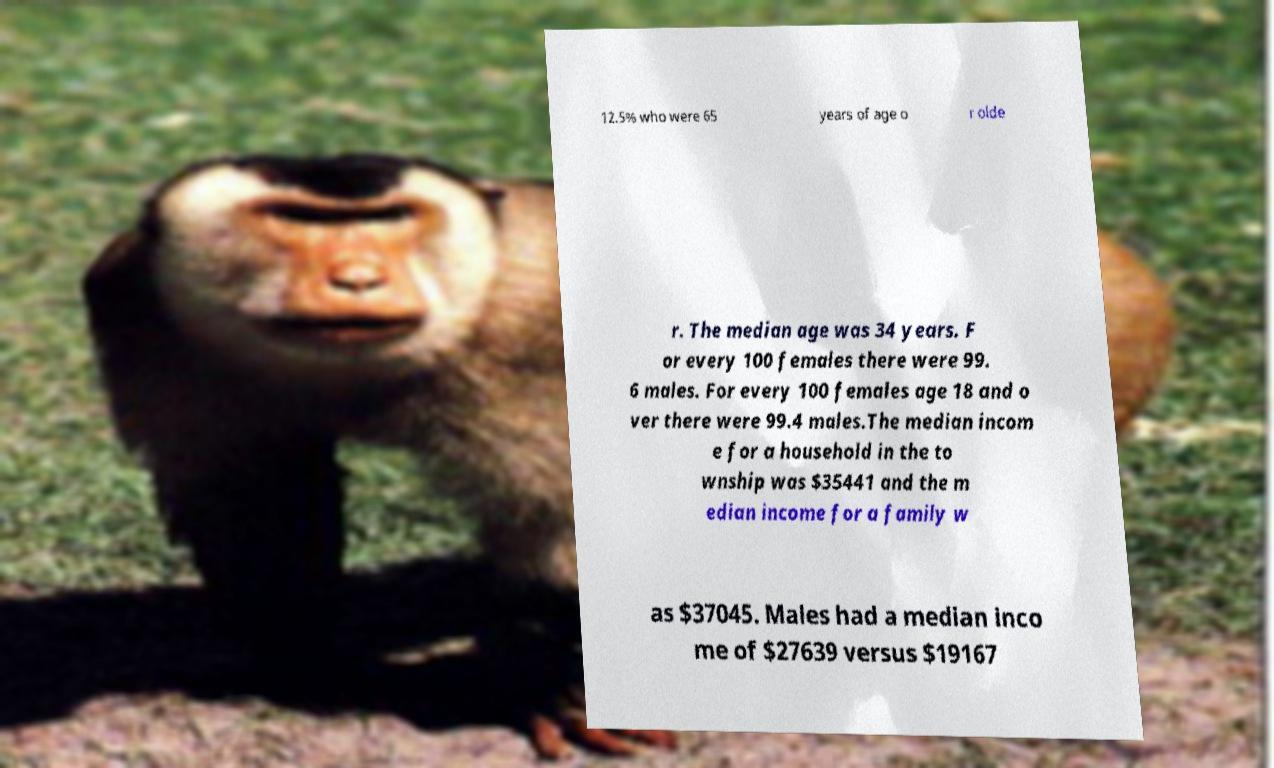Please read and relay the text visible in this image. What does it say? 12.5% who were 65 years of age o r olde r. The median age was 34 years. F or every 100 females there were 99. 6 males. For every 100 females age 18 and o ver there were 99.4 males.The median incom e for a household in the to wnship was $35441 and the m edian income for a family w as $37045. Males had a median inco me of $27639 versus $19167 